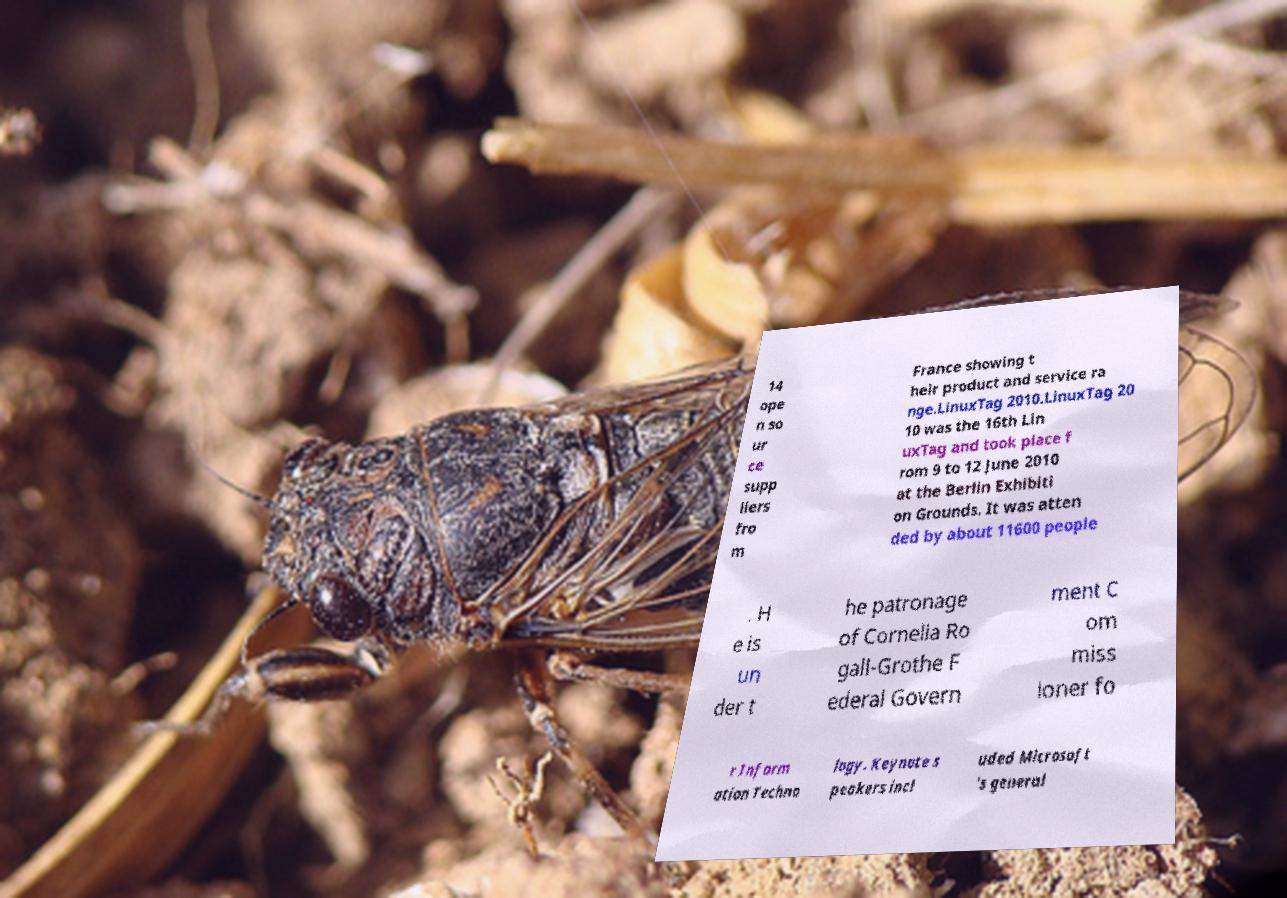For documentation purposes, I need the text within this image transcribed. Could you provide that? 14 ope n so ur ce supp liers fro m France showing t heir product and service ra nge.LinuxTag 2010.LinuxTag 20 10 was the 16th Lin uxTag and took place f rom 9 to 12 June 2010 at the Berlin Exhibiti on Grounds. It was atten ded by about 11600 people . H e is un der t he patronage of Cornelia Ro gall-Grothe F ederal Govern ment C om miss ioner fo r Inform ation Techno logy. Keynote s peakers incl uded Microsoft 's general 